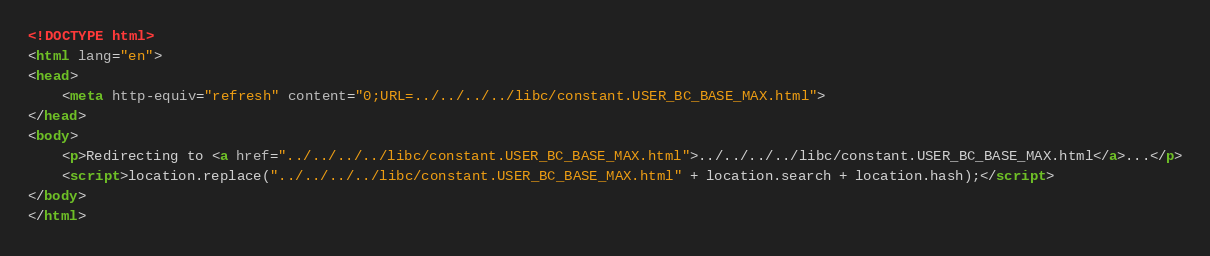Convert code to text. <code><loc_0><loc_0><loc_500><loc_500><_HTML_><!DOCTYPE html>
<html lang="en">
<head>
    <meta http-equiv="refresh" content="0;URL=../../../../libc/constant.USER_BC_BASE_MAX.html">
</head>
<body>
    <p>Redirecting to <a href="../../../../libc/constant.USER_BC_BASE_MAX.html">../../../../libc/constant.USER_BC_BASE_MAX.html</a>...</p>
    <script>location.replace("../../../../libc/constant.USER_BC_BASE_MAX.html" + location.search + location.hash);</script>
</body>
</html></code> 